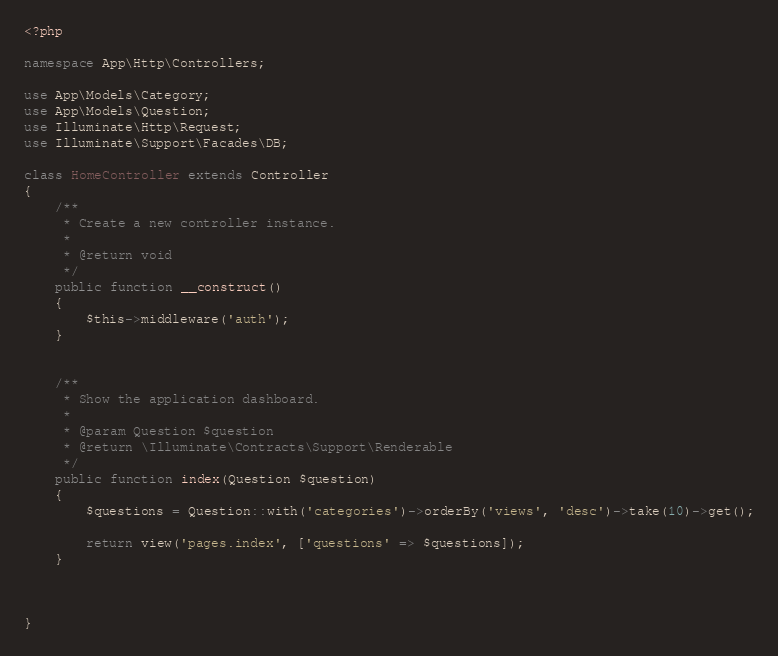<code> <loc_0><loc_0><loc_500><loc_500><_PHP_><?php

namespace App\Http\Controllers;

use App\Models\Category;
use App\Models\Question;
use Illuminate\Http\Request;
use Illuminate\Support\Facades\DB;

class HomeController extends Controller
{
    /**
     * Create a new controller instance.
     *
     * @return void
     */
    public function __construct()
    {
        $this->middleware('auth');
    }


    /**
     * Show the application dashboard.
     *
     * @param Question $question
     * @return \Illuminate\Contracts\Support\Renderable
     */
    public function index(Question $question)
    {
        $questions = Question::with('categories')->orderBy('views', 'desc')->take(10)->get();

        return view('pages.index', ['questions' => $questions]);
    }



}
</code> 